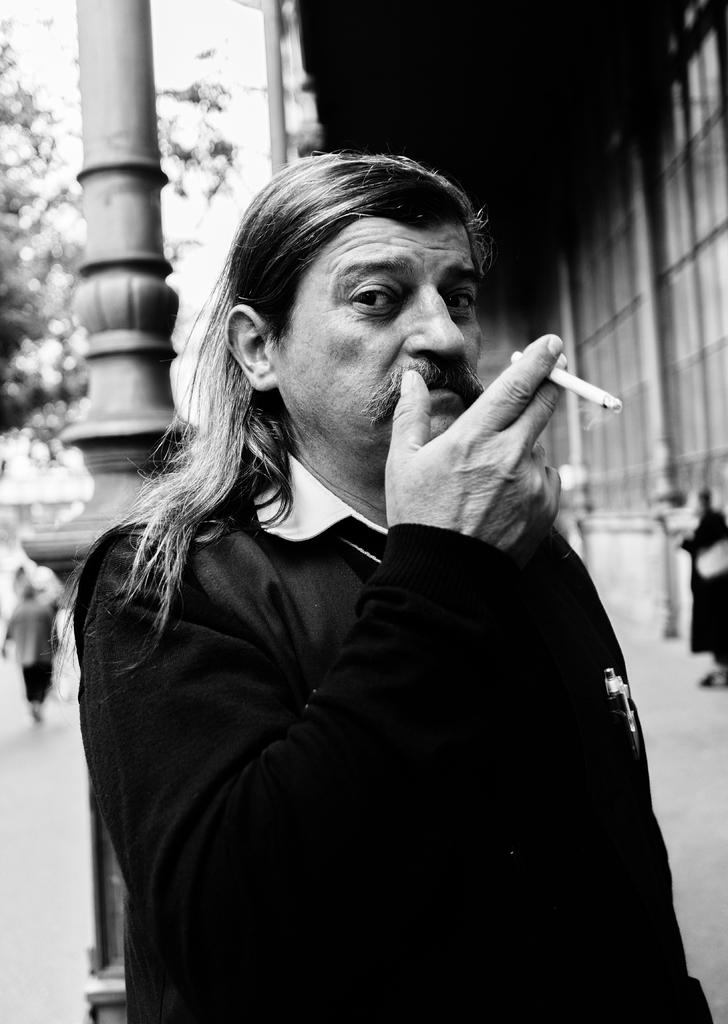What is the person in the image holding? The person is holding a cigarette. Can you describe the background of the image? The background of the image is blurred. What architectural features can be seen in the image? There are pillars visible in the image. What type of vegetation is present in the image? Trees are present in the image. What material is visible in the image? There is glass in the image. What type of structure is in the image? There is a wall in the image. How many people are in the image? There are people in the image. What type of bun is being served for dinner in the image? There is no bun or dinner present in the image. What punishment is being administered to the person in the image? There is no punishment being administered to the person in the image; they are simply holding a cigarette. 